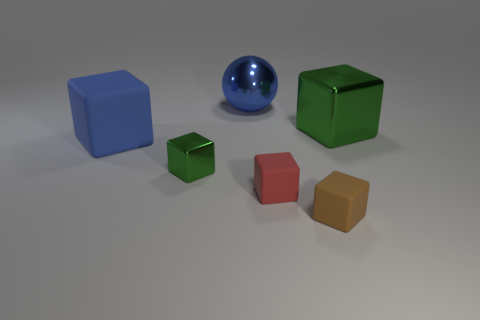What can you infer about the environment in which these objects are placed? The environment appears to be a controlled setting, likely a studio or a simulated setup, indicated by the uniform lighting and the seamless background. There are slight shadows under each object, confirming the presence of a light source above, and the lack of any distinct features or distractions in the background focuses attention solely on the objects themselves. 